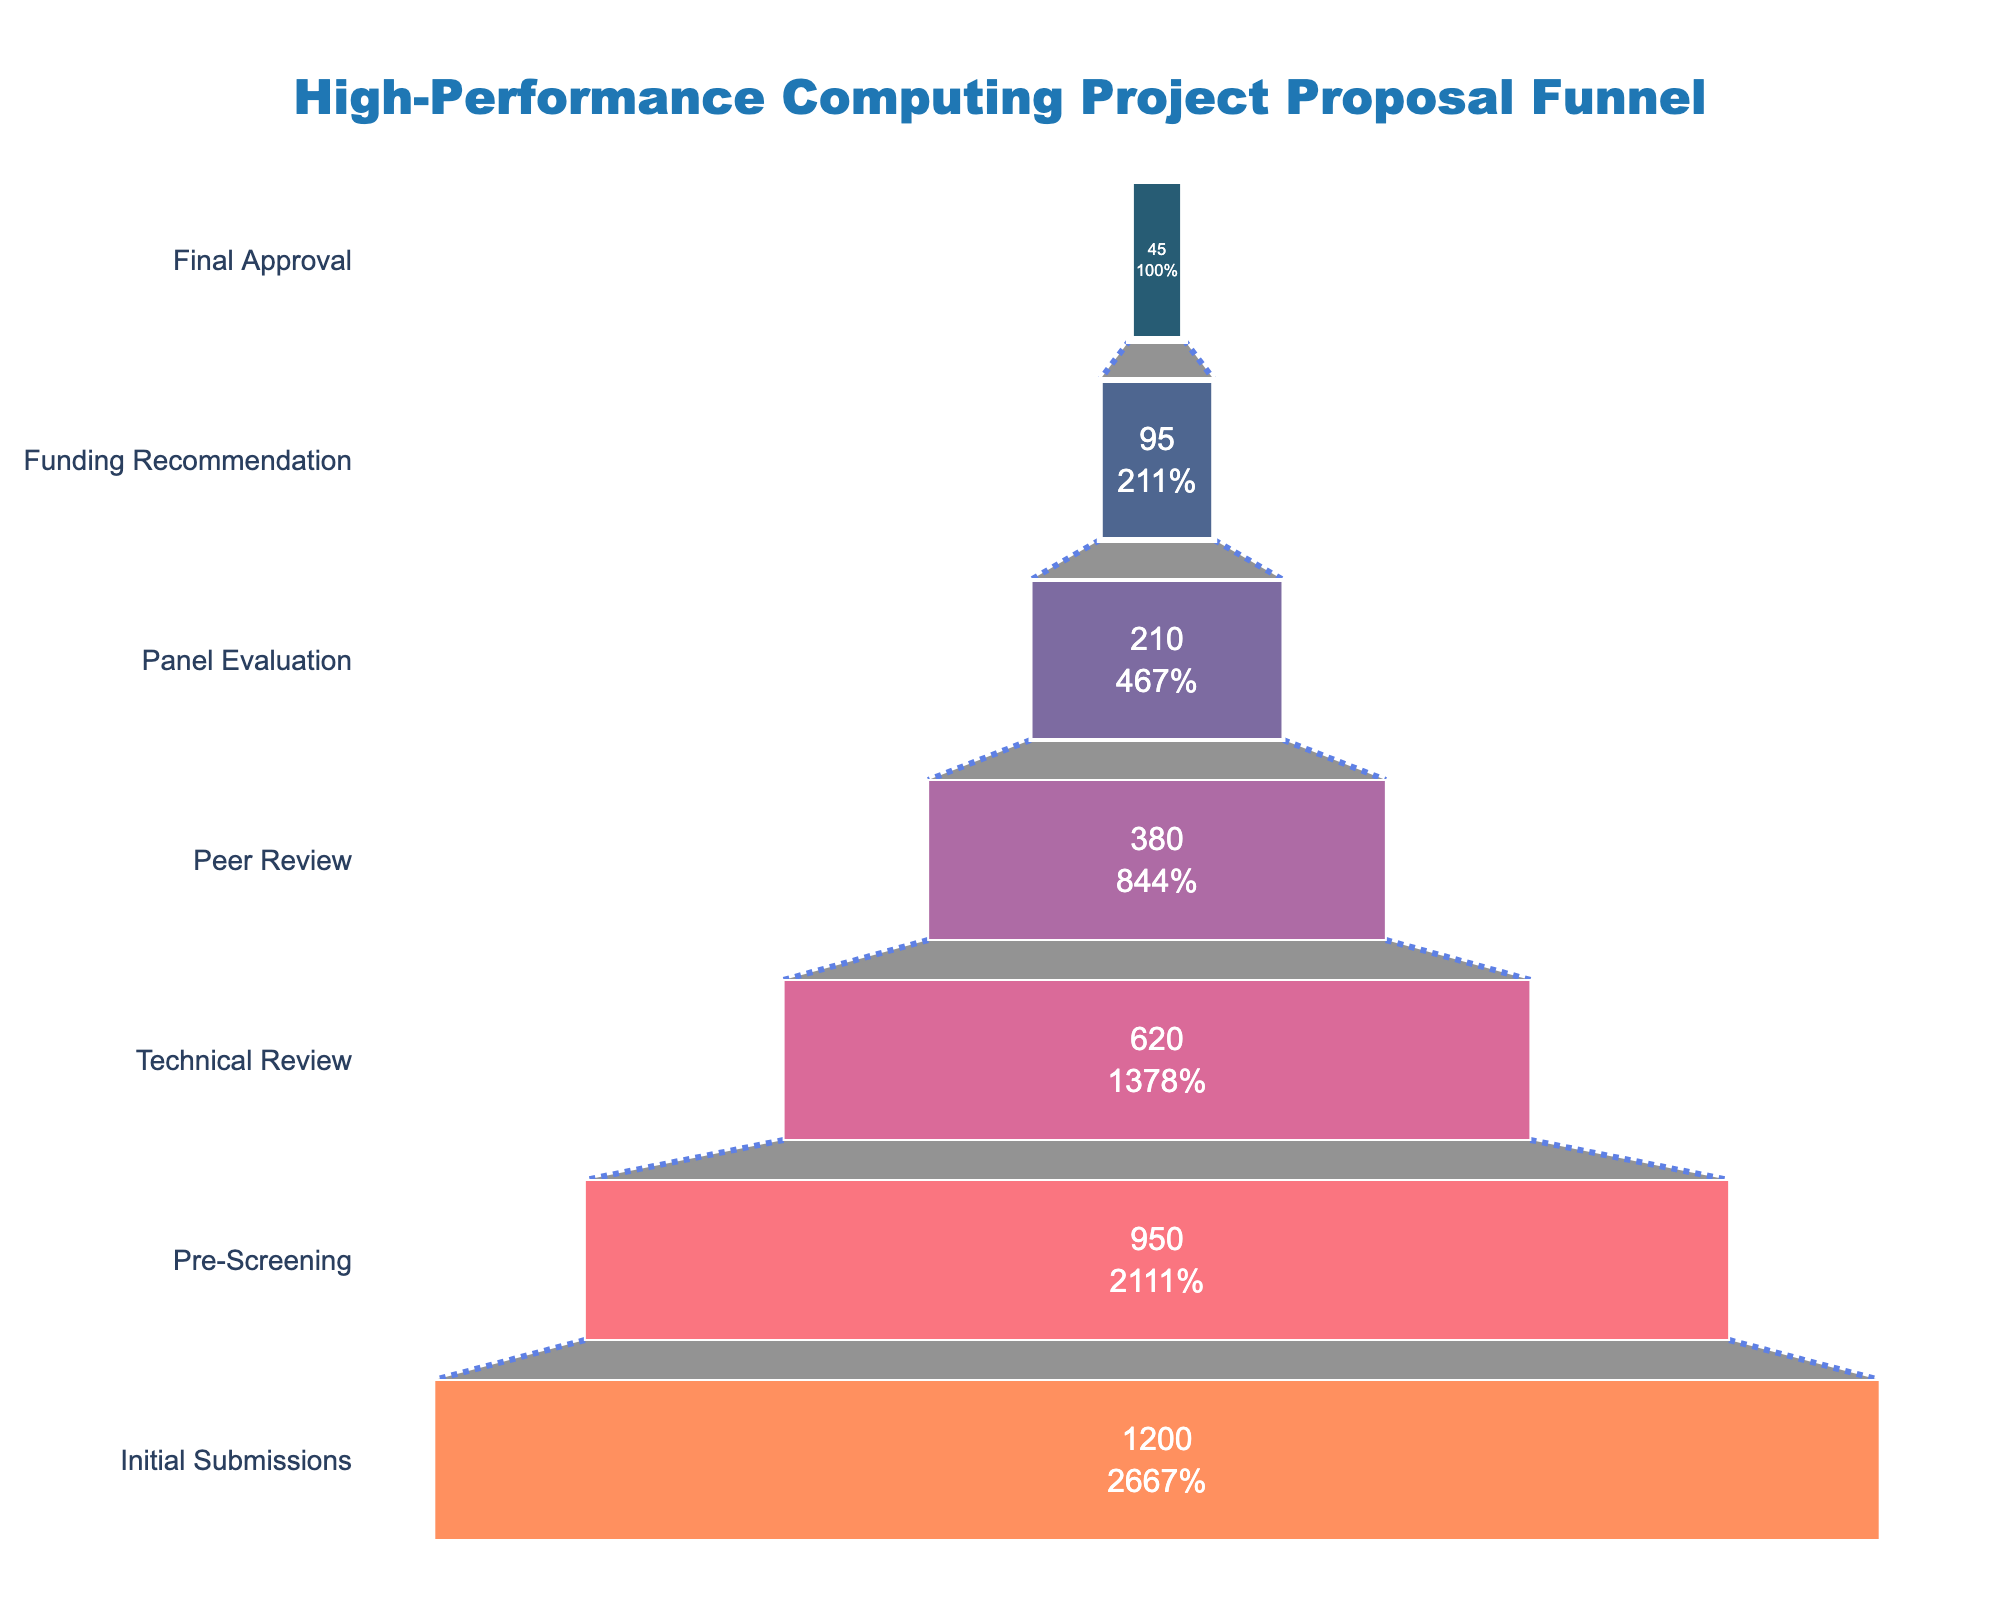What is the title of the funnel chart? The title is displayed at the top of the chart, and it reads "High-Performance Computing Project Proposal Funnel" in a large font.
Answer: High-Performance Computing Project Proposal Funnel What is the first stage in the process, and how many applications does it have? The first stage is listed at the bottom of the funnel, and it is "Initial Submissions" with 1,200 applications.
Answer: Initial Submissions, 1,200 How many applications reach the "Panel Evaluation" stage? By looking at the funnel, the number next to "Panel Evaluation" is visible. The number of applications at this stage is 210.
Answer: 210 What is the percentage drop from the "Initial Submissions" to the "Pre-Screening" stage? Calculate the drop percentage by subtracting the Pre-Screening applications from the Initial Submissions and then dividing by the Initial Submissions. The calculation is (1,200 - 950) / 1,200 = 0.2083, or approximately 20.83%.
Answer: 20.83% By comparing the stages, which stage has the greatest number of applications being removed? Compare the differences in application numbers between each consecutive stage. The biggest difference is between "Initial Submissions" (1,200) and "Pre-Screening" (950) which is a drop of 250 applications.
Answer: Initial Submissions to Pre-Screening How many total applications are left after the "Technical Review" stage? The total applications left at the "Technical Review" stage is the number below this stage. The quantity at this stage is 620.
Answer: 620 What are the two stages with the smallest number of applications, and what are their respective numbers? The stages with the smallest numbers are "Final Approval" and "Funding Recommendation," visible at the narrowest part of the funnel. Their respective numbers are 45 and 95.
Answer: Final Approval: 45, Funding Recommendation: 95 What is the average number of applications from "Pre-Screening" to "Final Approval"? Calculate the average by summing the numbers from "Pre-Screening" (950) to "Final Approval" (45) and then dividing by the number of stages (6 stages). The calculation is (950 + 620 + 380 + 210 + 95 + 45) / 6 = 383.33.
Answer: 383.33 What percentage of the applications that passed the "Peer Review" stage made it to the "Funding Recommendation" stage? Calculate the percentage by dividing the number at "Funding Recommendation" by the number at "Peer Review". The calculation is 95 / 380 = 0.25, which is 25%.
Answer: 25% Which stage has a color that is distinctively red, and how many applications are at this stage? The stage "Panel Evaluation" is represented in a distinctively red color, and it has 210 applications.
Answer: Panel Evaluation, 210 